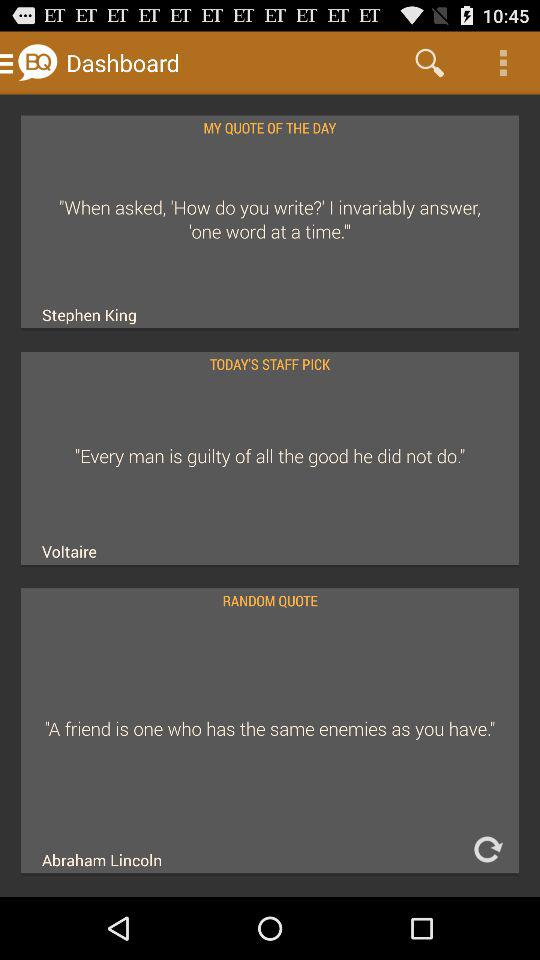What is the quote by Abraham Lincoln? The quote by Abraham Lincoln is "A friend is one who has the same enemies as you have". 